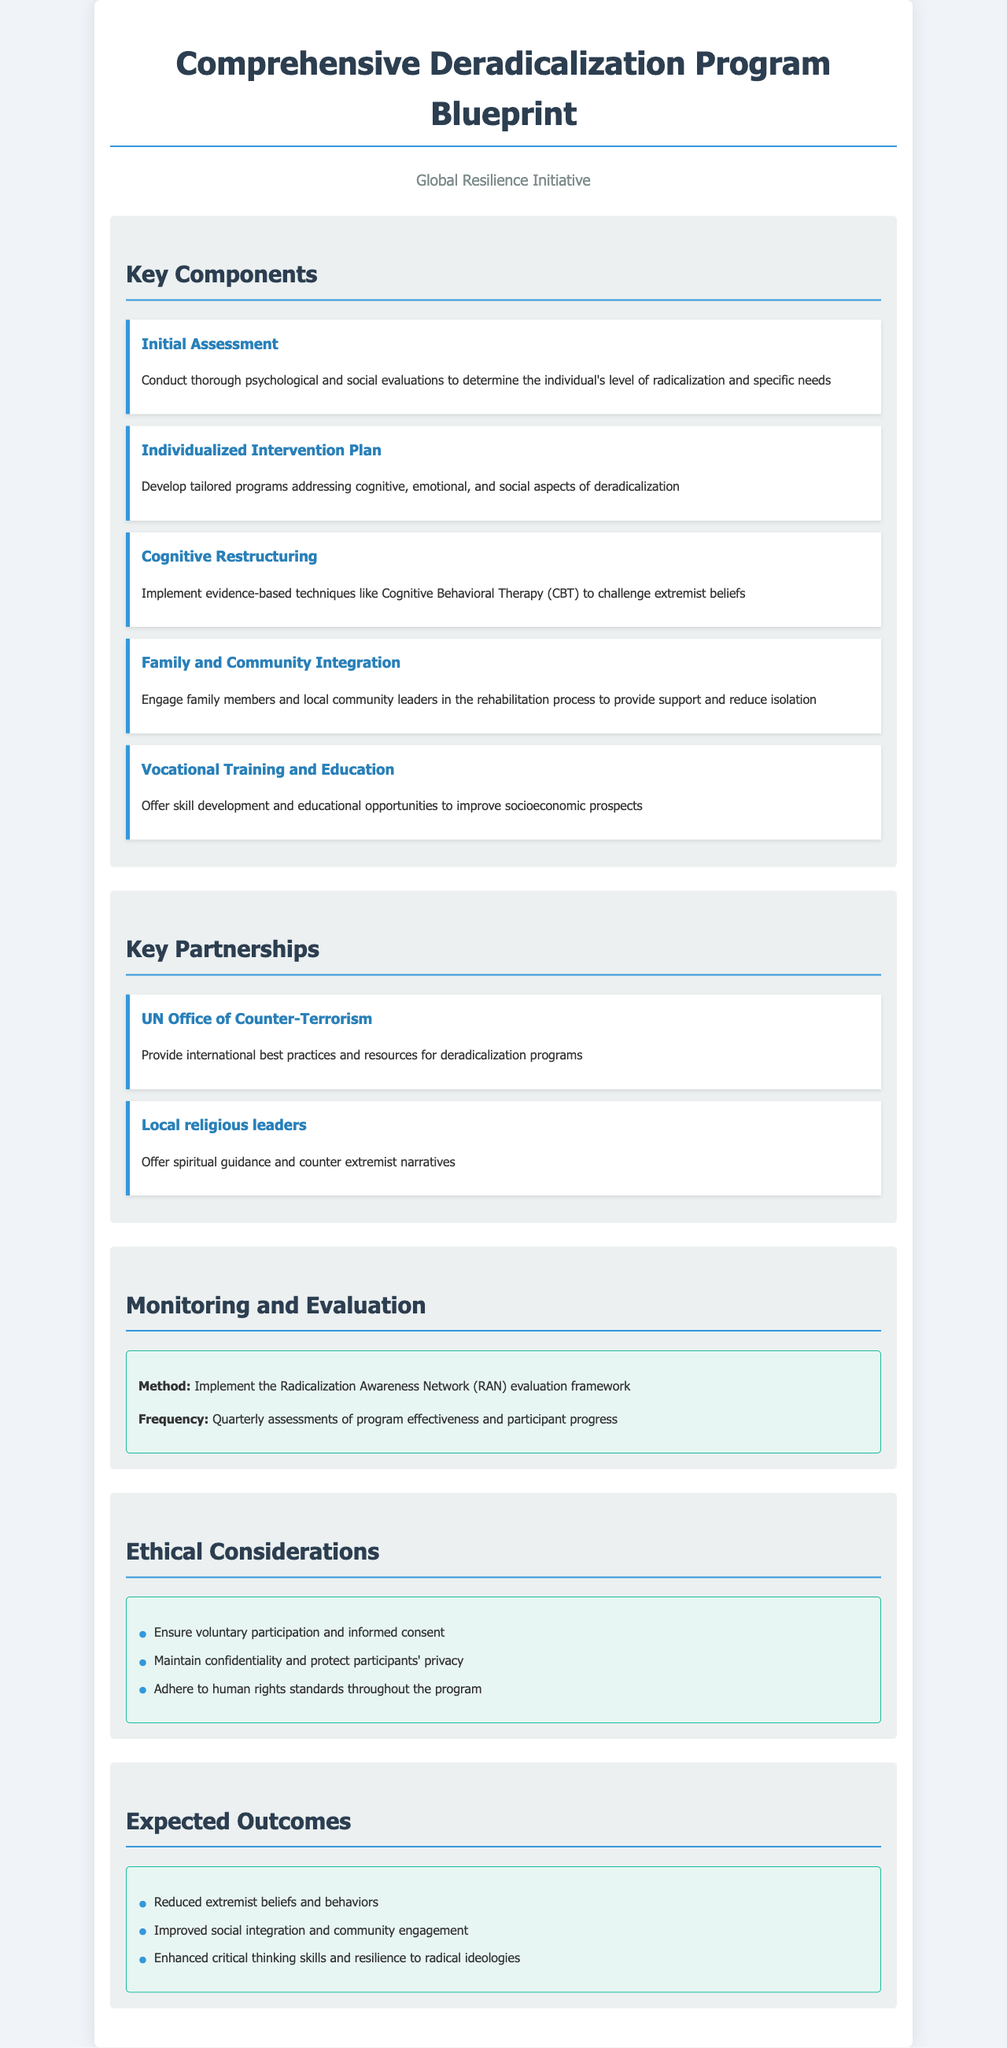What is the name of the organization that created the blueprint? The document mentions the organization as the Global Resilience Initiative, which is stated at the top of the document.
Answer: Global Resilience Initiative What is the first component of the deradicalization program? The first component is identified in the section titled "Key Components" and is described as the Initial Assessment.
Answer: Initial Assessment What type of therapy is used in cognitive restructuring? The document specifies that evidence-based techniques like Cognitive Behavioral Therapy (CBT) are implemented, detailed under the Cognitive Restructuring component.
Answer: Cognitive Behavioral Therapy (CBT) Who partners with the program to provide spiritual guidance? The partnerships section mentions local religious leaders as key partners in the deradicalization program.
Answer: Local religious leaders How often are assessments of the program's effectiveness conducted? The monitoring and evaluation section states that assessments occur quarterly, indicating the frequency of program evaluations.
Answer: Quarterly What is the expected outcome related to social integration? The expected outcome listed in the document is improved social integration and community engagement.
Answer: Improved social integration and community engagement What ethical consideration involves participants' rights? The document contains a bullet point regarding maintaining confidentiality and protecting participants' privacy, highlighting an important ethical consideration.
Answer: Protect participants' privacy What is the purpose of vocational training in the program? The vocational training and education component outlines that it aims to offer skill development and educational opportunities for better socioeconomic prospects.
Answer: Improve socioeconomic prospects Which evaluation framework is mentioned in the monitoring section? The monitoring section includes a specific framework, which is the Radicalization Awareness Network (RAN) evaluation framework.
Answer: Radicalization Awareness Network (RAN) 